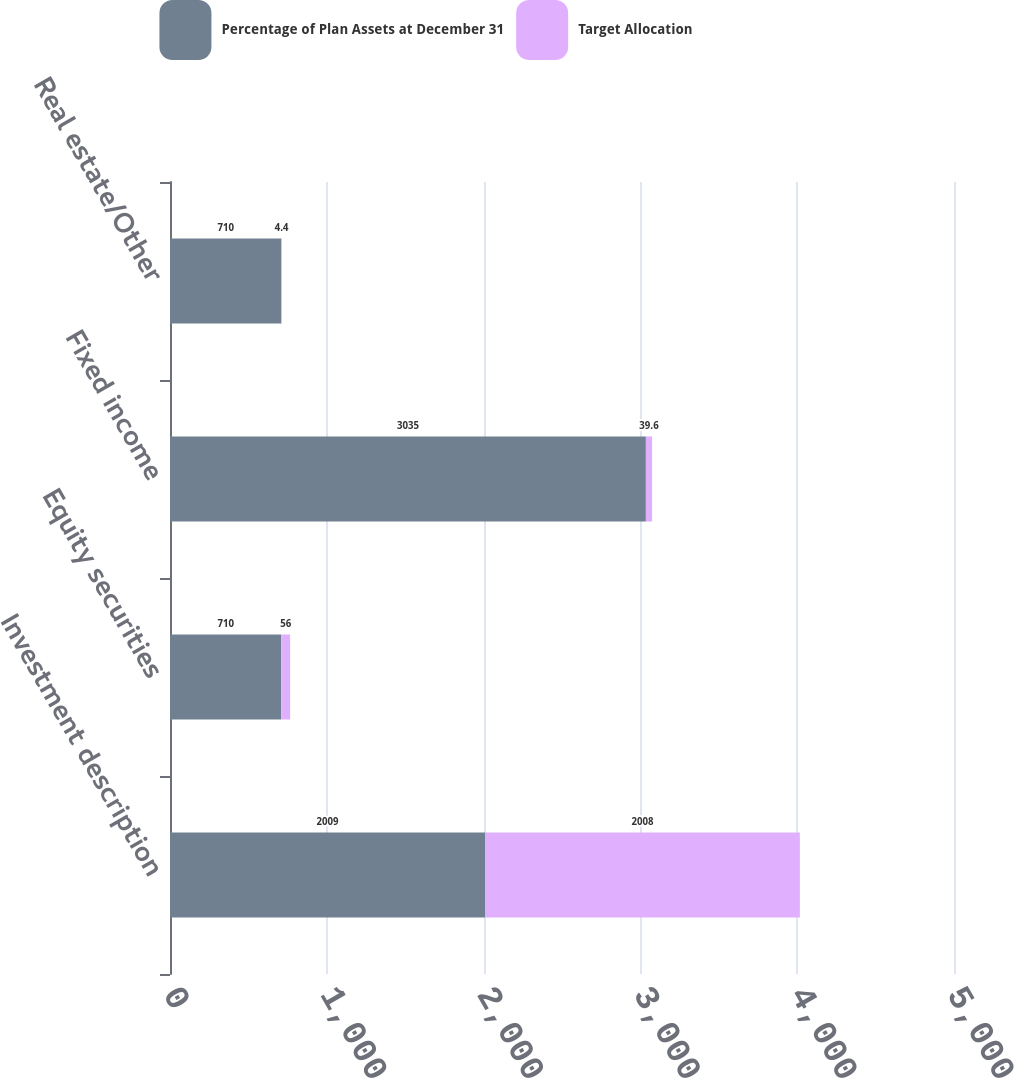<chart> <loc_0><loc_0><loc_500><loc_500><stacked_bar_chart><ecel><fcel>Investment description<fcel>Equity securities<fcel>Fixed income<fcel>Real estate/Other<nl><fcel>Percentage of Plan Assets at December 31<fcel>2009<fcel>710<fcel>3035<fcel>710<nl><fcel>Target Allocation<fcel>2008<fcel>56<fcel>39.6<fcel>4.4<nl></chart> 